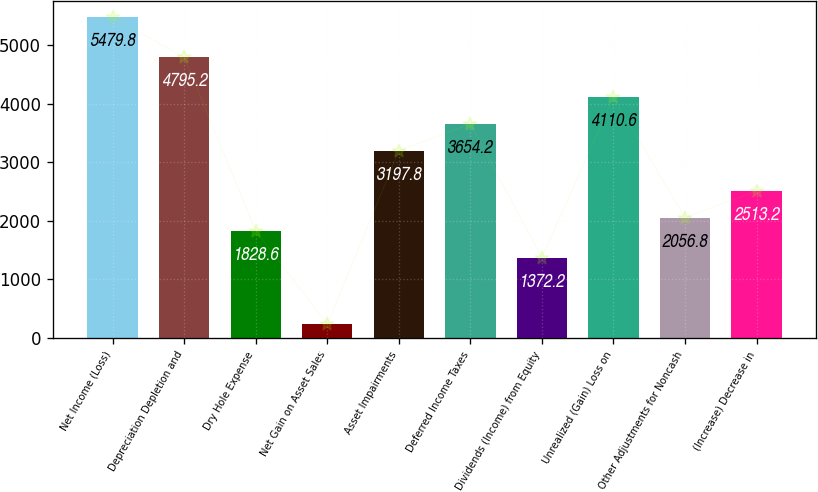<chart> <loc_0><loc_0><loc_500><loc_500><bar_chart><fcel>Net Income (Loss)<fcel>Depreciation Depletion and<fcel>Dry Hole Expense<fcel>Net Gain on Asset Sales<fcel>Asset Impairments<fcel>Deferred Income Taxes<fcel>Dividends (Income) from Equity<fcel>Unrealized (Gain) Loss on<fcel>Other Adjustments for Noncash<fcel>(Increase) Decrease in<nl><fcel>5479.8<fcel>4795.2<fcel>1828.6<fcel>231.2<fcel>3197.8<fcel>3654.2<fcel>1372.2<fcel>4110.6<fcel>2056.8<fcel>2513.2<nl></chart> 